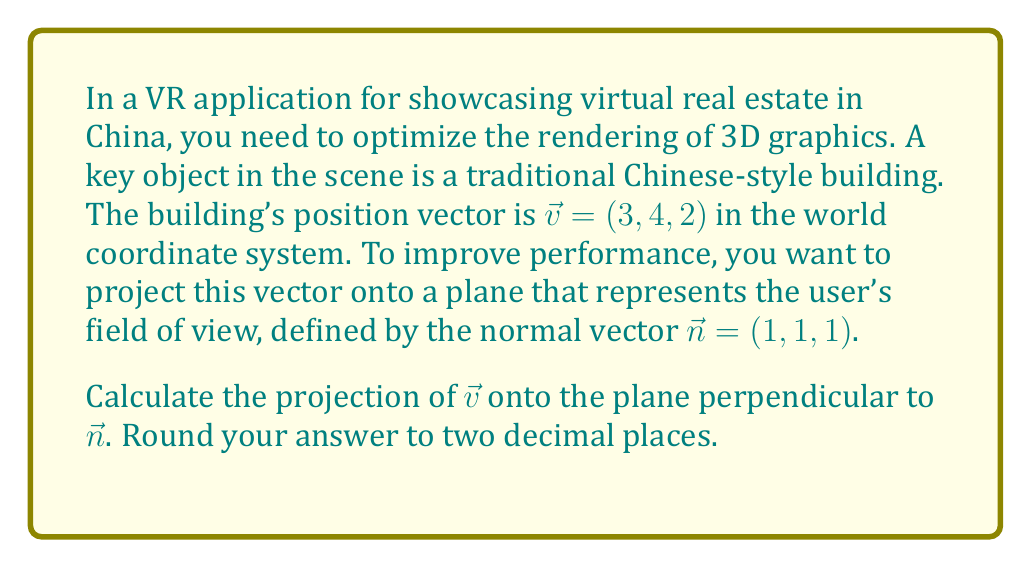Can you solve this math problem? To solve this problem, we'll follow these steps:

1) The projection of $\vec{v}$ onto the plane perpendicular to $\vec{n}$ is given by:

   $$\vec{v}_{\perp} = \vec{v} - \vec{v}_{\parallel}$$

   where $\vec{v}_{\parallel}$ is the projection of $\vec{v}$ onto $\vec{n}$.

2) We can calculate $\vec{v}_{\parallel}$ using the formula:

   $$\vec{v}_{\parallel} = \frac{\vec{v} \cdot \vec{n}}{\|\vec{n}\|^2} \vec{n}$$

3) First, let's calculate $\vec{v} \cdot \vec{n}$:
   
   $$\vec{v} \cdot \vec{n} = 3(1) + 4(1) + 2(1) = 9$$

4) Next, calculate $\|\vec{n}\|^2$:
   
   $$\|\vec{n}\|^2 = 1^2 + 1^2 + 1^2 = 3$$

5) Now we can calculate $\vec{v}_{\parallel}$:

   $$\vec{v}_{\parallel} = \frac{9}{3} (1, 1, 1) = (3, 3, 3)$$

6) Finally, we can calculate $\vec{v}_{\perp}$:

   $$\vec{v}_{\perp} = (3, 4, 2) - (3, 3, 3) = (0, 1, -1)$$

7) Rounding to two decimal places:

   $$\vec{v}_{\perp} = (0.00, 1.00, -1.00)$$
Answer: $(0.00, 1.00, -1.00)$ 